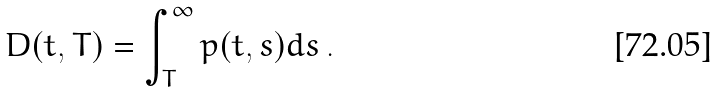Convert formula to latex. <formula><loc_0><loc_0><loc_500><loc_500>D ( t , T ) = \int _ { T } ^ { \infty } p ( t , s ) d s \, .</formula> 